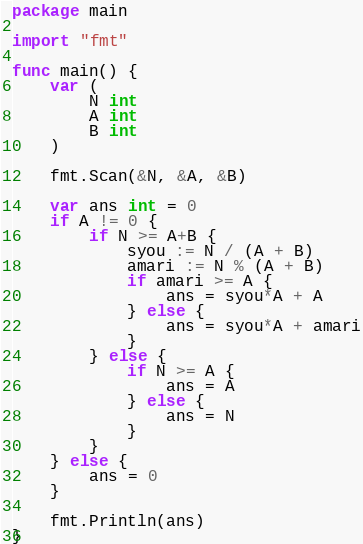<code> <loc_0><loc_0><loc_500><loc_500><_Go_>package main

import "fmt"

func main() {
	var (
		N int
		A int
		B int
	)

	fmt.Scan(&N, &A, &B)

	var ans int = 0
	if A != 0 {
		if N >= A+B {
			syou := N / (A + B)
			amari := N % (A + B)
			if amari >= A {
				ans = syou*A + A
			} else {
				ans = syou*A + amari
			}
		} else {
			if N >= A {
				ans = A
			} else {
				ans = N
			}
		}
	} else {
		ans = 0
	}

	fmt.Println(ans)
}
</code> 